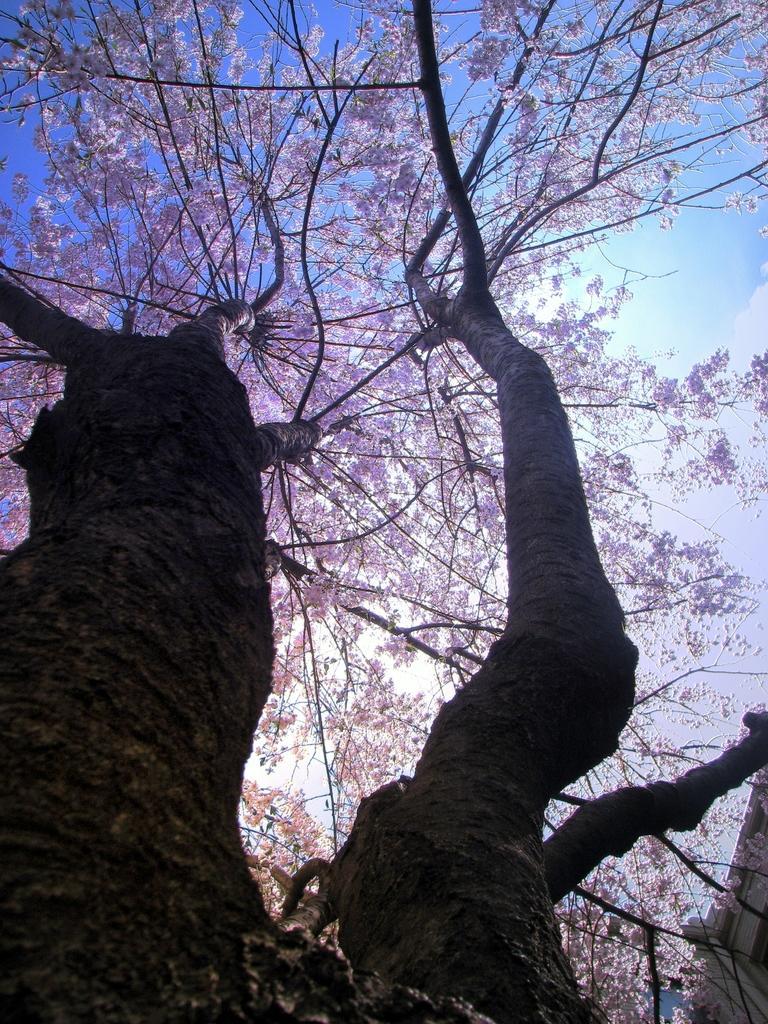Please provide a concise description of this image. In this picture I can observe a tree. There are violet color leaves to the tree. In the background there is sky. 